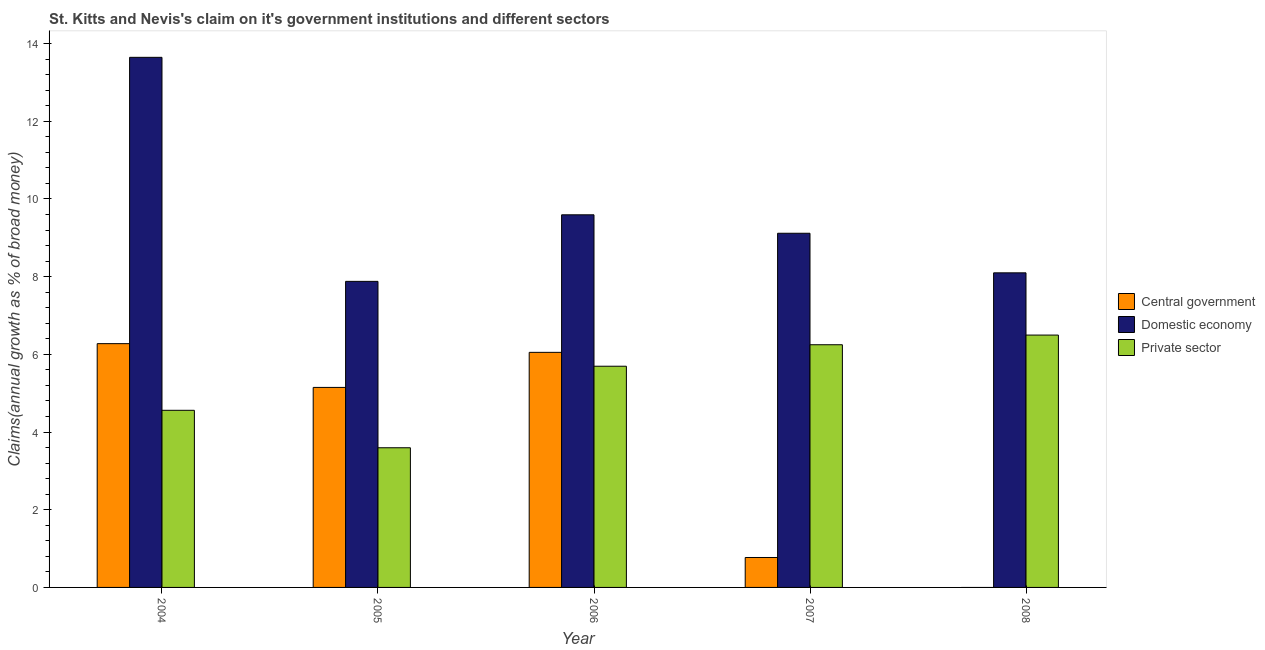How many different coloured bars are there?
Your answer should be compact. 3. Are the number of bars on each tick of the X-axis equal?
Your answer should be compact. No. How many bars are there on the 4th tick from the right?
Provide a short and direct response. 3. In how many cases, is the number of bars for a given year not equal to the number of legend labels?
Your response must be concise. 1. What is the percentage of claim on the domestic economy in 2008?
Provide a succinct answer. 8.1. Across all years, what is the maximum percentage of claim on the central government?
Ensure brevity in your answer.  6.28. Across all years, what is the minimum percentage of claim on the domestic economy?
Give a very brief answer. 7.88. What is the total percentage of claim on the central government in the graph?
Your response must be concise. 18.25. What is the difference between the percentage of claim on the domestic economy in 2005 and that in 2007?
Offer a terse response. -1.24. What is the difference between the percentage of claim on the domestic economy in 2007 and the percentage of claim on the private sector in 2004?
Provide a short and direct response. -4.53. What is the average percentage of claim on the central government per year?
Make the answer very short. 3.65. In the year 2004, what is the difference between the percentage of claim on the domestic economy and percentage of claim on the private sector?
Your answer should be compact. 0. In how many years, is the percentage of claim on the private sector greater than 8.4 %?
Give a very brief answer. 0. What is the ratio of the percentage of claim on the private sector in 2004 to that in 2008?
Offer a terse response. 0.7. What is the difference between the highest and the second highest percentage of claim on the central government?
Offer a very short reply. 0.22. What is the difference between the highest and the lowest percentage of claim on the private sector?
Your response must be concise. 2.9. Is the sum of the percentage of claim on the central government in 2004 and 2007 greater than the maximum percentage of claim on the domestic economy across all years?
Offer a terse response. Yes. How many years are there in the graph?
Offer a terse response. 5. What is the difference between two consecutive major ticks on the Y-axis?
Offer a terse response. 2. Does the graph contain grids?
Provide a succinct answer. No. How are the legend labels stacked?
Provide a succinct answer. Vertical. What is the title of the graph?
Offer a terse response. St. Kitts and Nevis's claim on it's government institutions and different sectors. Does "Ages 0-14" appear as one of the legend labels in the graph?
Provide a short and direct response. No. What is the label or title of the Y-axis?
Keep it short and to the point. Claims(annual growth as % of broad money). What is the Claims(annual growth as % of broad money) in Central government in 2004?
Offer a terse response. 6.28. What is the Claims(annual growth as % of broad money) of Domestic economy in 2004?
Provide a succinct answer. 13.65. What is the Claims(annual growth as % of broad money) in Private sector in 2004?
Provide a succinct answer. 4.56. What is the Claims(annual growth as % of broad money) in Central government in 2005?
Give a very brief answer. 5.15. What is the Claims(annual growth as % of broad money) in Domestic economy in 2005?
Offer a terse response. 7.88. What is the Claims(annual growth as % of broad money) of Private sector in 2005?
Provide a succinct answer. 3.6. What is the Claims(annual growth as % of broad money) in Central government in 2006?
Offer a very short reply. 6.05. What is the Claims(annual growth as % of broad money) of Domestic economy in 2006?
Keep it short and to the point. 9.59. What is the Claims(annual growth as % of broad money) of Private sector in 2006?
Your answer should be very brief. 5.69. What is the Claims(annual growth as % of broad money) in Central government in 2007?
Offer a terse response. 0.77. What is the Claims(annual growth as % of broad money) of Domestic economy in 2007?
Provide a succinct answer. 9.12. What is the Claims(annual growth as % of broad money) in Private sector in 2007?
Your answer should be compact. 6.25. What is the Claims(annual growth as % of broad money) of Central government in 2008?
Make the answer very short. 0. What is the Claims(annual growth as % of broad money) in Domestic economy in 2008?
Give a very brief answer. 8.1. What is the Claims(annual growth as % of broad money) in Private sector in 2008?
Your answer should be very brief. 6.5. Across all years, what is the maximum Claims(annual growth as % of broad money) of Central government?
Your answer should be compact. 6.28. Across all years, what is the maximum Claims(annual growth as % of broad money) in Domestic economy?
Provide a short and direct response. 13.65. Across all years, what is the maximum Claims(annual growth as % of broad money) in Private sector?
Ensure brevity in your answer.  6.5. Across all years, what is the minimum Claims(annual growth as % of broad money) in Central government?
Your response must be concise. 0. Across all years, what is the minimum Claims(annual growth as % of broad money) of Domestic economy?
Make the answer very short. 7.88. Across all years, what is the minimum Claims(annual growth as % of broad money) in Private sector?
Make the answer very short. 3.6. What is the total Claims(annual growth as % of broad money) of Central government in the graph?
Give a very brief answer. 18.25. What is the total Claims(annual growth as % of broad money) in Domestic economy in the graph?
Keep it short and to the point. 48.33. What is the total Claims(annual growth as % of broad money) in Private sector in the graph?
Offer a terse response. 26.59. What is the difference between the Claims(annual growth as % of broad money) in Central government in 2004 and that in 2005?
Offer a very short reply. 1.13. What is the difference between the Claims(annual growth as % of broad money) in Domestic economy in 2004 and that in 2005?
Provide a succinct answer. 5.77. What is the difference between the Claims(annual growth as % of broad money) of Private sector in 2004 and that in 2005?
Make the answer very short. 0.96. What is the difference between the Claims(annual growth as % of broad money) of Central government in 2004 and that in 2006?
Make the answer very short. 0.22. What is the difference between the Claims(annual growth as % of broad money) of Domestic economy in 2004 and that in 2006?
Your answer should be very brief. 4.05. What is the difference between the Claims(annual growth as % of broad money) of Private sector in 2004 and that in 2006?
Ensure brevity in your answer.  -1.13. What is the difference between the Claims(annual growth as % of broad money) in Central government in 2004 and that in 2007?
Offer a very short reply. 5.5. What is the difference between the Claims(annual growth as % of broad money) of Domestic economy in 2004 and that in 2007?
Provide a succinct answer. 4.53. What is the difference between the Claims(annual growth as % of broad money) of Private sector in 2004 and that in 2007?
Keep it short and to the point. -1.69. What is the difference between the Claims(annual growth as % of broad money) of Domestic economy in 2004 and that in 2008?
Your answer should be very brief. 5.55. What is the difference between the Claims(annual growth as % of broad money) in Private sector in 2004 and that in 2008?
Provide a succinct answer. -1.94. What is the difference between the Claims(annual growth as % of broad money) in Central government in 2005 and that in 2006?
Your answer should be compact. -0.9. What is the difference between the Claims(annual growth as % of broad money) in Domestic economy in 2005 and that in 2006?
Provide a succinct answer. -1.71. What is the difference between the Claims(annual growth as % of broad money) in Private sector in 2005 and that in 2006?
Your answer should be very brief. -2.1. What is the difference between the Claims(annual growth as % of broad money) in Central government in 2005 and that in 2007?
Your answer should be compact. 4.38. What is the difference between the Claims(annual growth as % of broad money) in Domestic economy in 2005 and that in 2007?
Offer a very short reply. -1.24. What is the difference between the Claims(annual growth as % of broad money) in Private sector in 2005 and that in 2007?
Your answer should be compact. -2.65. What is the difference between the Claims(annual growth as % of broad money) in Domestic economy in 2005 and that in 2008?
Give a very brief answer. -0.22. What is the difference between the Claims(annual growth as % of broad money) in Private sector in 2005 and that in 2008?
Make the answer very short. -2.9. What is the difference between the Claims(annual growth as % of broad money) of Central government in 2006 and that in 2007?
Provide a short and direct response. 5.28. What is the difference between the Claims(annual growth as % of broad money) in Domestic economy in 2006 and that in 2007?
Give a very brief answer. 0.47. What is the difference between the Claims(annual growth as % of broad money) in Private sector in 2006 and that in 2007?
Provide a short and direct response. -0.55. What is the difference between the Claims(annual growth as % of broad money) in Domestic economy in 2006 and that in 2008?
Keep it short and to the point. 1.49. What is the difference between the Claims(annual growth as % of broad money) of Private sector in 2006 and that in 2008?
Offer a terse response. -0.8. What is the difference between the Claims(annual growth as % of broad money) in Domestic economy in 2007 and that in 2008?
Make the answer very short. 1.02. What is the difference between the Claims(annual growth as % of broad money) of Private sector in 2007 and that in 2008?
Offer a very short reply. -0.25. What is the difference between the Claims(annual growth as % of broad money) in Central government in 2004 and the Claims(annual growth as % of broad money) in Domestic economy in 2005?
Your response must be concise. -1.6. What is the difference between the Claims(annual growth as % of broad money) in Central government in 2004 and the Claims(annual growth as % of broad money) in Private sector in 2005?
Make the answer very short. 2.68. What is the difference between the Claims(annual growth as % of broad money) in Domestic economy in 2004 and the Claims(annual growth as % of broad money) in Private sector in 2005?
Ensure brevity in your answer.  10.05. What is the difference between the Claims(annual growth as % of broad money) in Central government in 2004 and the Claims(annual growth as % of broad money) in Domestic economy in 2006?
Your response must be concise. -3.32. What is the difference between the Claims(annual growth as % of broad money) in Central government in 2004 and the Claims(annual growth as % of broad money) in Private sector in 2006?
Offer a very short reply. 0.58. What is the difference between the Claims(annual growth as % of broad money) of Domestic economy in 2004 and the Claims(annual growth as % of broad money) of Private sector in 2006?
Offer a very short reply. 7.95. What is the difference between the Claims(annual growth as % of broad money) in Central government in 2004 and the Claims(annual growth as % of broad money) in Domestic economy in 2007?
Your answer should be very brief. -2.84. What is the difference between the Claims(annual growth as % of broad money) of Central government in 2004 and the Claims(annual growth as % of broad money) of Private sector in 2007?
Make the answer very short. 0.03. What is the difference between the Claims(annual growth as % of broad money) of Domestic economy in 2004 and the Claims(annual growth as % of broad money) of Private sector in 2007?
Provide a succinct answer. 7.4. What is the difference between the Claims(annual growth as % of broad money) of Central government in 2004 and the Claims(annual growth as % of broad money) of Domestic economy in 2008?
Provide a succinct answer. -1.82. What is the difference between the Claims(annual growth as % of broad money) in Central government in 2004 and the Claims(annual growth as % of broad money) in Private sector in 2008?
Offer a terse response. -0.22. What is the difference between the Claims(annual growth as % of broad money) of Domestic economy in 2004 and the Claims(annual growth as % of broad money) of Private sector in 2008?
Keep it short and to the point. 7.15. What is the difference between the Claims(annual growth as % of broad money) of Central government in 2005 and the Claims(annual growth as % of broad money) of Domestic economy in 2006?
Offer a very short reply. -4.44. What is the difference between the Claims(annual growth as % of broad money) of Central government in 2005 and the Claims(annual growth as % of broad money) of Private sector in 2006?
Your answer should be very brief. -0.55. What is the difference between the Claims(annual growth as % of broad money) of Domestic economy in 2005 and the Claims(annual growth as % of broad money) of Private sector in 2006?
Your answer should be compact. 2.18. What is the difference between the Claims(annual growth as % of broad money) of Central government in 2005 and the Claims(annual growth as % of broad money) of Domestic economy in 2007?
Ensure brevity in your answer.  -3.97. What is the difference between the Claims(annual growth as % of broad money) of Central government in 2005 and the Claims(annual growth as % of broad money) of Private sector in 2007?
Keep it short and to the point. -1.1. What is the difference between the Claims(annual growth as % of broad money) in Domestic economy in 2005 and the Claims(annual growth as % of broad money) in Private sector in 2007?
Keep it short and to the point. 1.63. What is the difference between the Claims(annual growth as % of broad money) of Central government in 2005 and the Claims(annual growth as % of broad money) of Domestic economy in 2008?
Provide a short and direct response. -2.95. What is the difference between the Claims(annual growth as % of broad money) of Central government in 2005 and the Claims(annual growth as % of broad money) of Private sector in 2008?
Your answer should be very brief. -1.35. What is the difference between the Claims(annual growth as % of broad money) in Domestic economy in 2005 and the Claims(annual growth as % of broad money) in Private sector in 2008?
Give a very brief answer. 1.38. What is the difference between the Claims(annual growth as % of broad money) in Central government in 2006 and the Claims(annual growth as % of broad money) in Domestic economy in 2007?
Offer a terse response. -3.07. What is the difference between the Claims(annual growth as % of broad money) of Central government in 2006 and the Claims(annual growth as % of broad money) of Private sector in 2007?
Offer a terse response. -0.2. What is the difference between the Claims(annual growth as % of broad money) in Domestic economy in 2006 and the Claims(annual growth as % of broad money) in Private sector in 2007?
Give a very brief answer. 3.34. What is the difference between the Claims(annual growth as % of broad money) of Central government in 2006 and the Claims(annual growth as % of broad money) of Domestic economy in 2008?
Ensure brevity in your answer.  -2.05. What is the difference between the Claims(annual growth as % of broad money) of Central government in 2006 and the Claims(annual growth as % of broad money) of Private sector in 2008?
Give a very brief answer. -0.44. What is the difference between the Claims(annual growth as % of broad money) in Domestic economy in 2006 and the Claims(annual growth as % of broad money) in Private sector in 2008?
Offer a terse response. 3.1. What is the difference between the Claims(annual growth as % of broad money) of Central government in 2007 and the Claims(annual growth as % of broad money) of Domestic economy in 2008?
Your response must be concise. -7.33. What is the difference between the Claims(annual growth as % of broad money) of Central government in 2007 and the Claims(annual growth as % of broad money) of Private sector in 2008?
Make the answer very short. -5.73. What is the difference between the Claims(annual growth as % of broad money) of Domestic economy in 2007 and the Claims(annual growth as % of broad money) of Private sector in 2008?
Ensure brevity in your answer.  2.62. What is the average Claims(annual growth as % of broad money) in Central government per year?
Provide a short and direct response. 3.65. What is the average Claims(annual growth as % of broad money) of Domestic economy per year?
Give a very brief answer. 9.67. What is the average Claims(annual growth as % of broad money) in Private sector per year?
Give a very brief answer. 5.32. In the year 2004, what is the difference between the Claims(annual growth as % of broad money) in Central government and Claims(annual growth as % of broad money) in Domestic economy?
Your answer should be compact. -7.37. In the year 2004, what is the difference between the Claims(annual growth as % of broad money) of Central government and Claims(annual growth as % of broad money) of Private sector?
Offer a very short reply. 1.72. In the year 2004, what is the difference between the Claims(annual growth as % of broad money) of Domestic economy and Claims(annual growth as % of broad money) of Private sector?
Ensure brevity in your answer.  9.09. In the year 2005, what is the difference between the Claims(annual growth as % of broad money) in Central government and Claims(annual growth as % of broad money) in Domestic economy?
Provide a succinct answer. -2.73. In the year 2005, what is the difference between the Claims(annual growth as % of broad money) of Central government and Claims(annual growth as % of broad money) of Private sector?
Offer a terse response. 1.55. In the year 2005, what is the difference between the Claims(annual growth as % of broad money) of Domestic economy and Claims(annual growth as % of broad money) of Private sector?
Provide a succinct answer. 4.28. In the year 2006, what is the difference between the Claims(annual growth as % of broad money) of Central government and Claims(annual growth as % of broad money) of Domestic economy?
Offer a very short reply. -3.54. In the year 2006, what is the difference between the Claims(annual growth as % of broad money) in Central government and Claims(annual growth as % of broad money) in Private sector?
Offer a terse response. 0.36. In the year 2006, what is the difference between the Claims(annual growth as % of broad money) of Domestic economy and Claims(annual growth as % of broad money) of Private sector?
Provide a succinct answer. 3.9. In the year 2007, what is the difference between the Claims(annual growth as % of broad money) in Central government and Claims(annual growth as % of broad money) in Domestic economy?
Provide a succinct answer. -8.35. In the year 2007, what is the difference between the Claims(annual growth as % of broad money) in Central government and Claims(annual growth as % of broad money) in Private sector?
Your answer should be compact. -5.48. In the year 2007, what is the difference between the Claims(annual growth as % of broad money) in Domestic economy and Claims(annual growth as % of broad money) in Private sector?
Give a very brief answer. 2.87. In the year 2008, what is the difference between the Claims(annual growth as % of broad money) in Domestic economy and Claims(annual growth as % of broad money) in Private sector?
Your answer should be very brief. 1.6. What is the ratio of the Claims(annual growth as % of broad money) in Central government in 2004 to that in 2005?
Offer a terse response. 1.22. What is the ratio of the Claims(annual growth as % of broad money) of Domestic economy in 2004 to that in 2005?
Ensure brevity in your answer.  1.73. What is the ratio of the Claims(annual growth as % of broad money) in Private sector in 2004 to that in 2005?
Give a very brief answer. 1.27. What is the ratio of the Claims(annual growth as % of broad money) in Central government in 2004 to that in 2006?
Make the answer very short. 1.04. What is the ratio of the Claims(annual growth as % of broad money) in Domestic economy in 2004 to that in 2006?
Keep it short and to the point. 1.42. What is the ratio of the Claims(annual growth as % of broad money) in Private sector in 2004 to that in 2006?
Make the answer very short. 0.8. What is the ratio of the Claims(annual growth as % of broad money) of Central government in 2004 to that in 2007?
Give a very brief answer. 8.14. What is the ratio of the Claims(annual growth as % of broad money) in Domestic economy in 2004 to that in 2007?
Make the answer very short. 1.5. What is the ratio of the Claims(annual growth as % of broad money) in Private sector in 2004 to that in 2007?
Your answer should be very brief. 0.73. What is the ratio of the Claims(annual growth as % of broad money) of Domestic economy in 2004 to that in 2008?
Offer a very short reply. 1.69. What is the ratio of the Claims(annual growth as % of broad money) in Private sector in 2004 to that in 2008?
Give a very brief answer. 0.7. What is the ratio of the Claims(annual growth as % of broad money) in Central government in 2005 to that in 2006?
Provide a succinct answer. 0.85. What is the ratio of the Claims(annual growth as % of broad money) of Domestic economy in 2005 to that in 2006?
Make the answer very short. 0.82. What is the ratio of the Claims(annual growth as % of broad money) in Private sector in 2005 to that in 2006?
Offer a very short reply. 0.63. What is the ratio of the Claims(annual growth as % of broad money) in Central government in 2005 to that in 2007?
Your answer should be very brief. 6.68. What is the ratio of the Claims(annual growth as % of broad money) in Domestic economy in 2005 to that in 2007?
Ensure brevity in your answer.  0.86. What is the ratio of the Claims(annual growth as % of broad money) in Private sector in 2005 to that in 2007?
Give a very brief answer. 0.58. What is the ratio of the Claims(annual growth as % of broad money) of Domestic economy in 2005 to that in 2008?
Your answer should be compact. 0.97. What is the ratio of the Claims(annual growth as % of broad money) of Private sector in 2005 to that in 2008?
Ensure brevity in your answer.  0.55. What is the ratio of the Claims(annual growth as % of broad money) of Central government in 2006 to that in 2007?
Ensure brevity in your answer.  7.85. What is the ratio of the Claims(annual growth as % of broad money) of Domestic economy in 2006 to that in 2007?
Your answer should be compact. 1.05. What is the ratio of the Claims(annual growth as % of broad money) in Private sector in 2006 to that in 2007?
Your answer should be very brief. 0.91. What is the ratio of the Claims(annual growth as % of broad money) of Domestic economy in 2006 to that in 2008?
Provide a short and direct response. 1.18. What is the ratio of the Claims(annual growth as % of broad money) of Private sector in 2006 to that in 2008?
Your answer should be very brief. 0.88. What is the ratio of the Claims(annual growth as % of broad money) of Domestic economy in 2007 to that in 2008?
Your response must be concise. 1.13. What is the ratio of the Claims(annual growth as % of broad money) of Private sector in 2007 to that in 2008?
Keep it short and to the point. 0.96. What is the difference between the highest and the second highest Claims(annual growth as % of broad money) in Central government?
Keep it short and to the point. 0.22. What is the difference between the highest and the second highest Claims(annual growth as % of broad money) of Domestic economy?
Offer a very short reply. 4.05. What is the difference between the highest and the second highest Claims(annual growth as % of broad money) of Private sector?
Provide a succinct answer. 0.25. What is the difference between the highest and the lowest Claims(annual growth as % of broad money) in Central government?
Your answer should be compact. 6.28. What is the difference between the highest and the lowest Claims(annual growth as % of broad money) of Domestic economy?
Make the answer very short. 5.77. What is the difference between the highest and the lowest Claims(annual growth as % of broad money) in Private sector?
Ensure brevity in your answer.  2.9. 